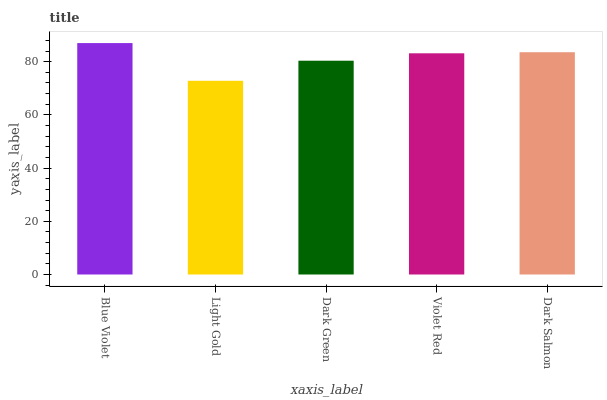Is Blue Violet the maximum?
Answer yes or no. Yes. Is Dark Green the minimum?
Answer yes or no. No. Is Dark Green the maximum?
Answer yes or no. No. Is Dark Green greater than Light Gold?
Answer yes or no. Yes. Is Light Gold less than Dark Green?
Answer yes or no. Yes. Is Light Gold greater than Dark Green?
Answer yes or no. No. Is Dark Green less than Light Gold?
Answer yes or no. No. Is Violet Red the high median?
Answer yes or no. Yes. Is Violet Red the low median?
Answer yes or no. Yes. Is Light Gold the high median?
Answer yes or no. No. Is Dark Salmon the low median?
Answer yes or no. No. 